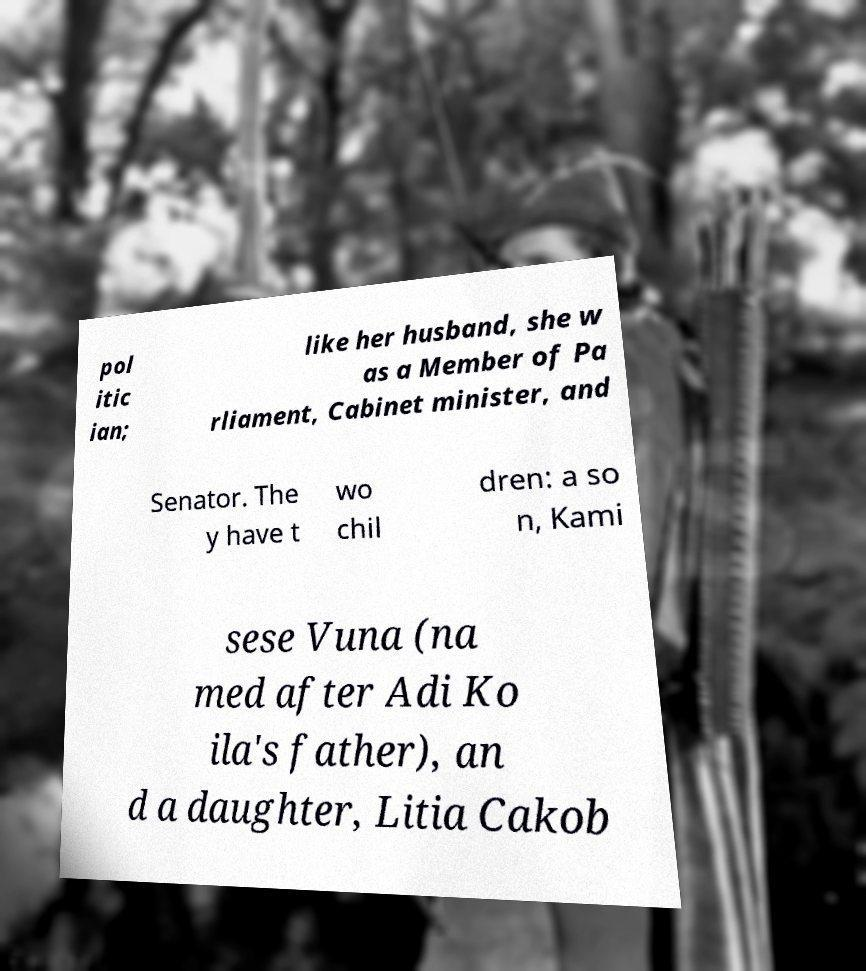Could you extract and type out the text from this image? pol itic ian; like her husband, she w as a Member of Pa rliament, Cabinet minister, and Senator. The y have t wo chil dren: a so n, Kami sese Vuna (na med after Adi Ko ila's father), an d a daughter, Litia Cakob 